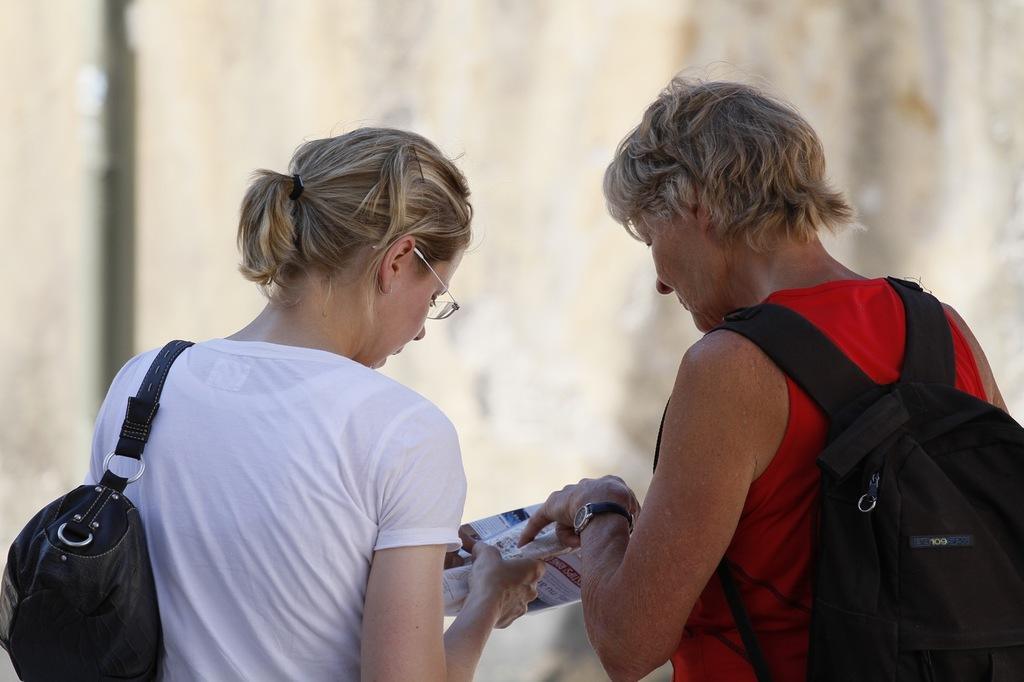How many people are present in the image? There are two men and one woman in the image. What is the woman wearing on her back? The woman is wearing a backpack in the image. What is the woman holding in her hand? The woman is holding a paper in her hand. What type of accessory is the woman wearing on her shoulder? The woman is wearing a handbag in the image. What type of bird can be seen bursting out of the backpack in the image? There is no bird present in the image, and the backpack is not bursting open. 